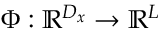<formula> <loc_0><loc_0><loc_500><loc_500>\Phi \colon \mathbb { R } ^ { D _ { x } } \rightarrow \mathbb { R } ^ { L }</formula> 